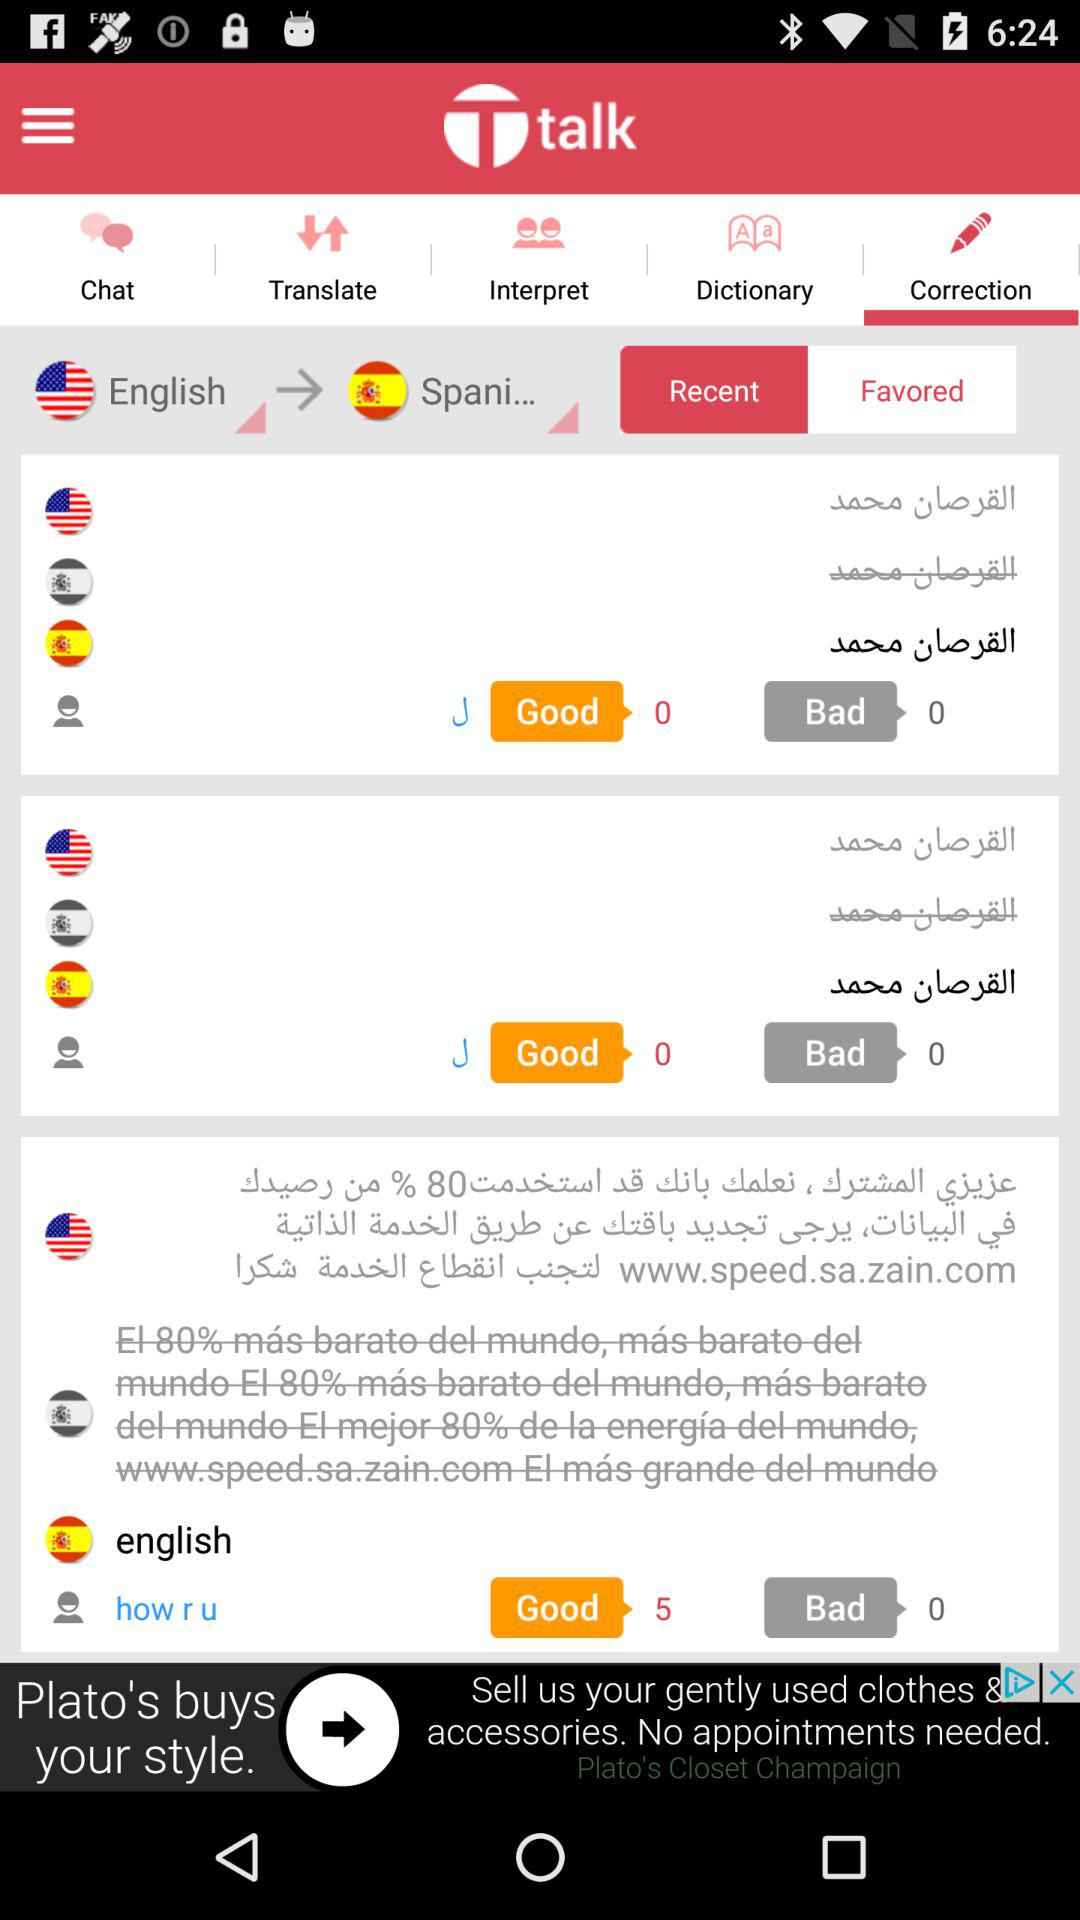How many languages does the user have access to?
Answer the question using a single word or phrase. 3 